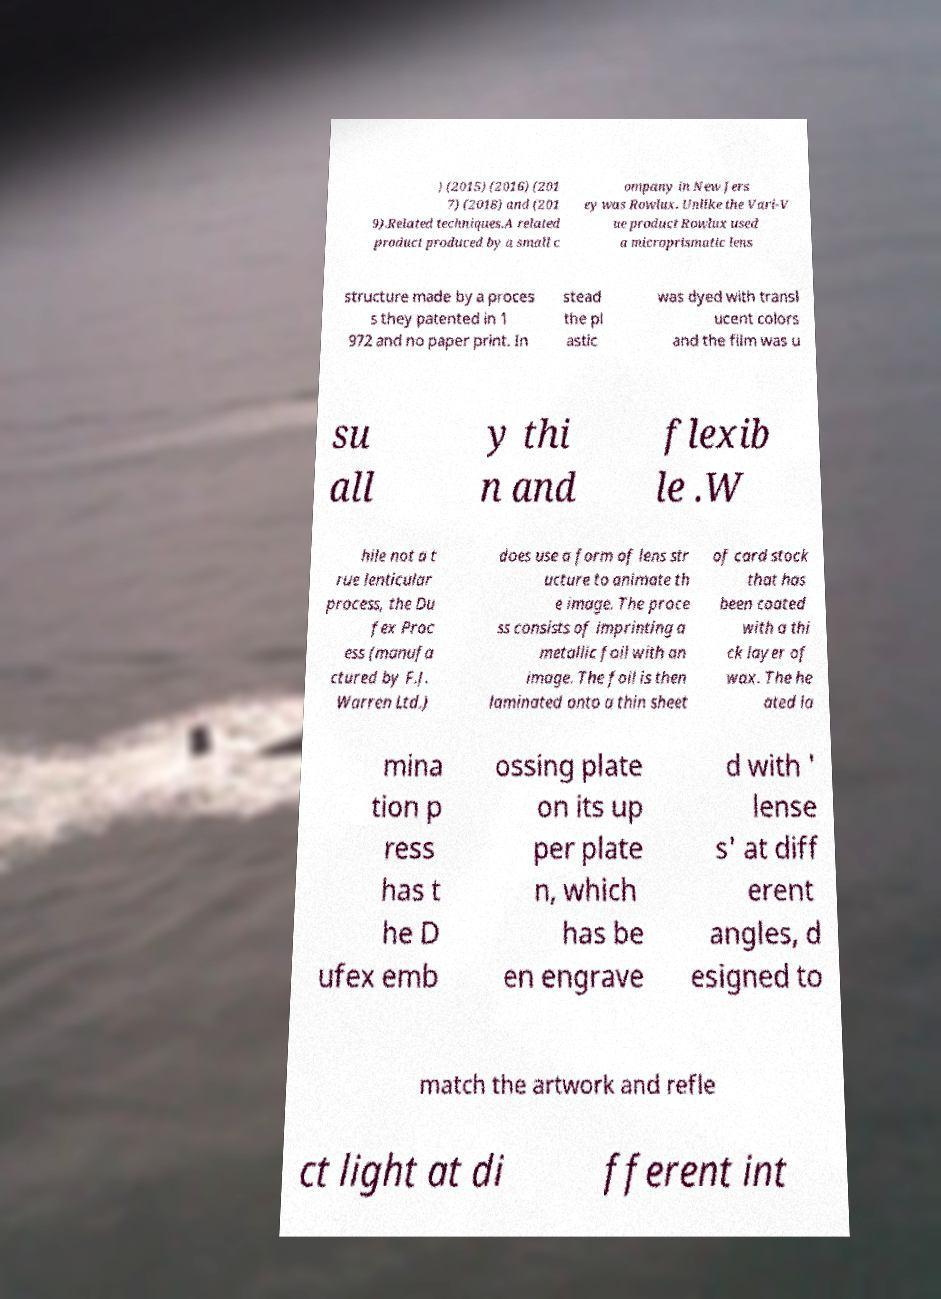Can you read and provide the text displayed in the image?This photo seems to have some interesting text. Can you extract and type it out for me? ) (2015) (2016) (201 7) (2018) and (201 9).Related techniques.A related product produced by a small c ompany in New Jers ey was Rowlux. Unlike the Vari-V ue product Rowlux used a microprismatic lens structure made by a proces s they patented in 1 972 and no paper print. In stead the pl astic was dyed with transl ucent colors and the film was u su all y thi n and flexib le .W hile not a t rue lenticular process, the Du fex Proc ess (manufa ctured by F.J. Warren Ltd.) does use a form of lens str ucture to animate th e image. The proce ss consists of imprinting a metallic foil with an image. The foil is then laminated onto a thin sheet of card stock that has been coated with a thi ck layer of wax. The he ated la mina tion p ress has t he D ufex emb ossing plate on its up per plate n, which has be en engrave d with ' lense s' at diff erent angles, d esigned to match the artwork and refle ct light at di fferent int 